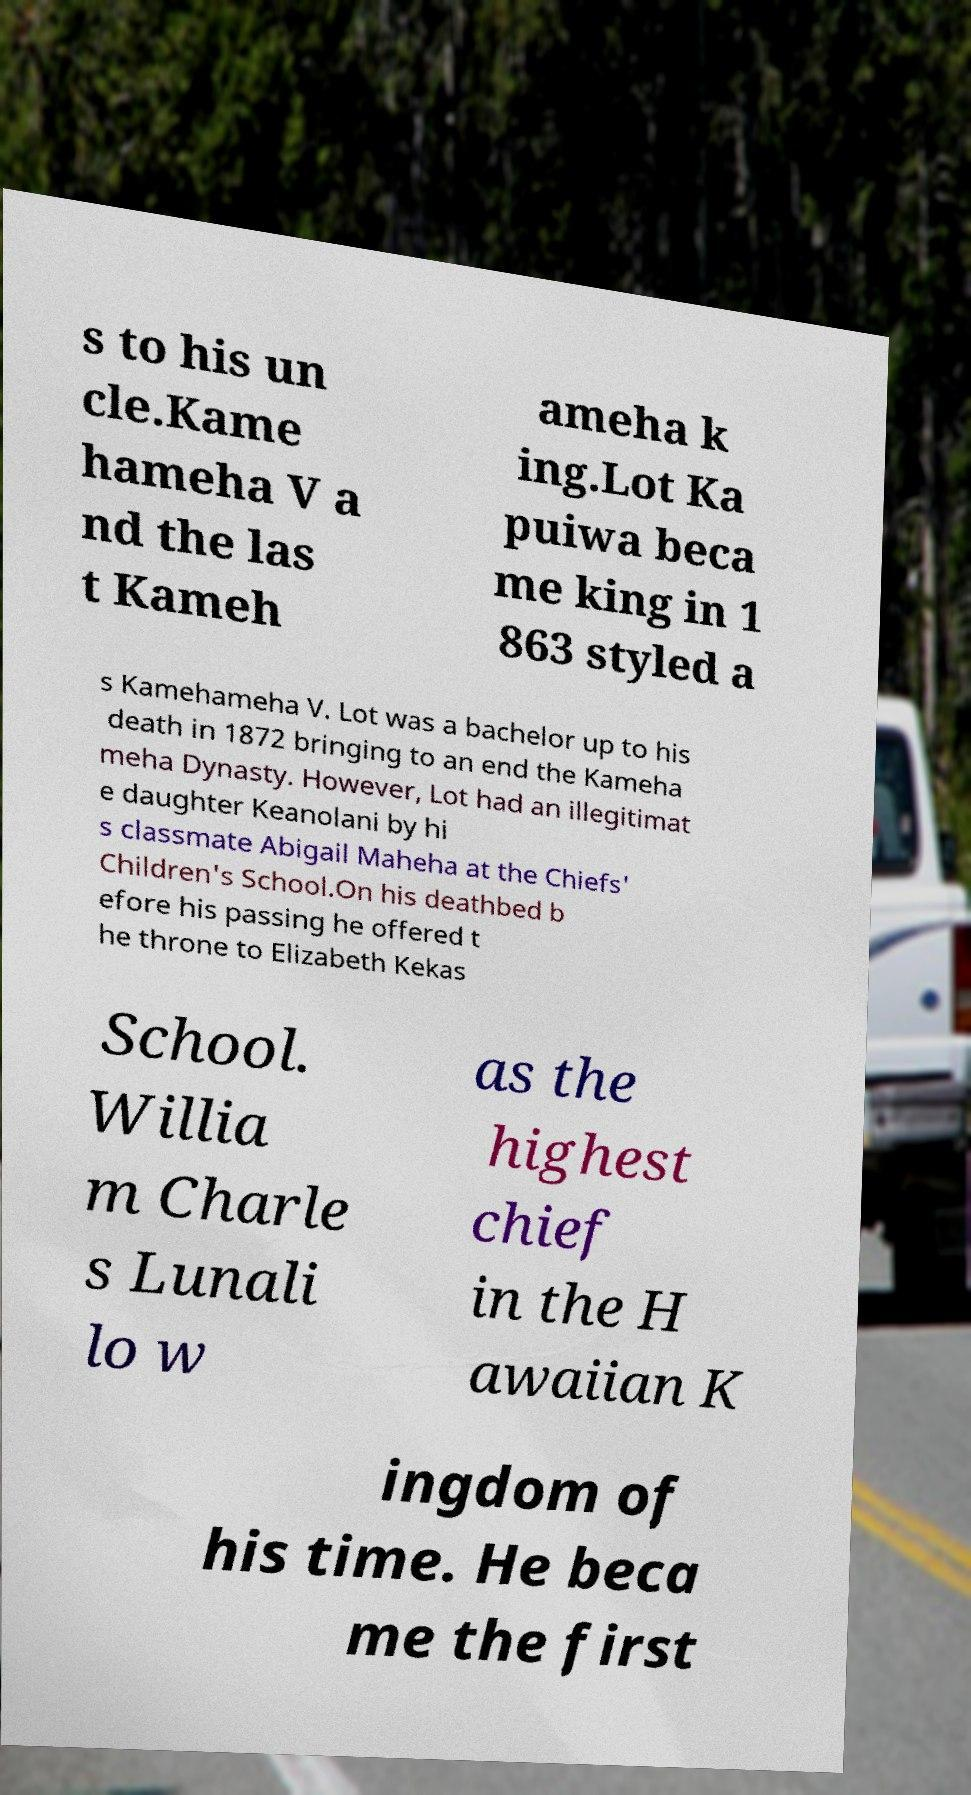Could you assist in decoding the text presented in this image and type it out clearly? s to his un cle.Kame hameha V a nd the las t Kameh ameha k ing.Lot Ka puiwa beca me king in 1 863 styled a s Kamehameha V. Lot was a bachelor up to his death in 1872 bringing to an end the Kameha meha Dynasty. However, Lot had an illegitimat e daughter Keanolani by hi s classmate Abigail Maheha at the Chiefs' Children's School.On his deathbed b efore his passing he offered t he throne to Elizabeth Kekas School. Willia m Charle s Lunali lo w as the highest chief in the H awaiian K ingdom of his time. He beca me the first 